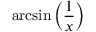Convert formula to latex. <formula><loc_0><loc_0><loc_500><loc_500>\arcsin \left ( { \frac { 1 } { x } } \right )</formula> 